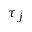Convert formula to latex. <formula><loc_0><loc_0><loc_500><loc_500>\tau _ { j }</formula> 